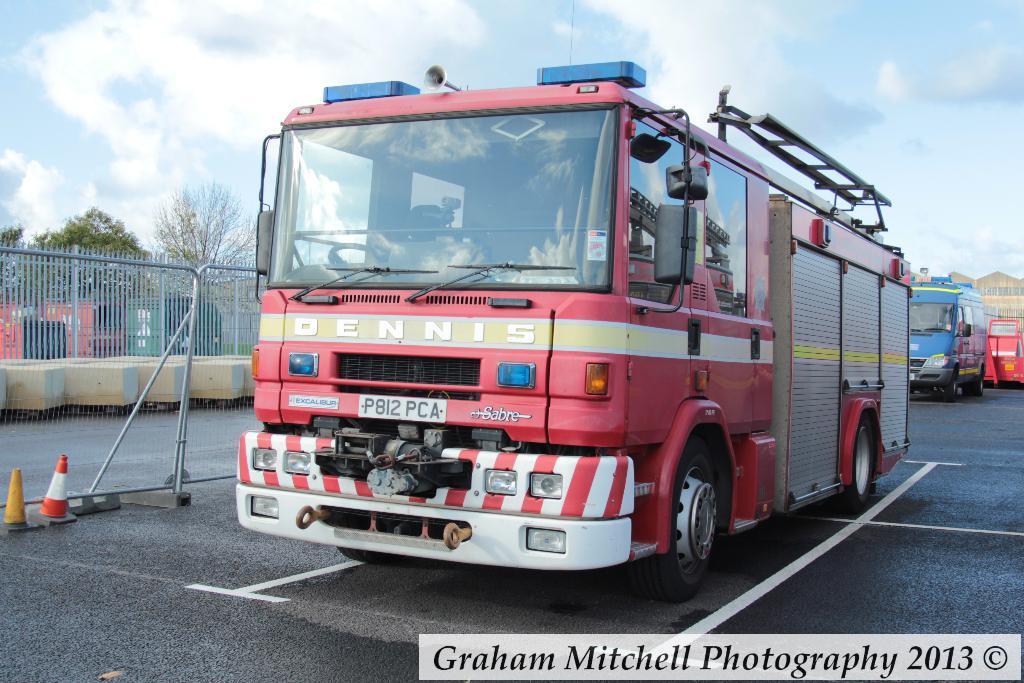In one or two sentences, can you explain what this image depicts? In this picture we can observe a red color vehicle moving on the road. We can observe traffic cones and a railing here. In the background there is another vehicle which is in blue color. In the left side there are trees. In the background there is a sky with clouds. 